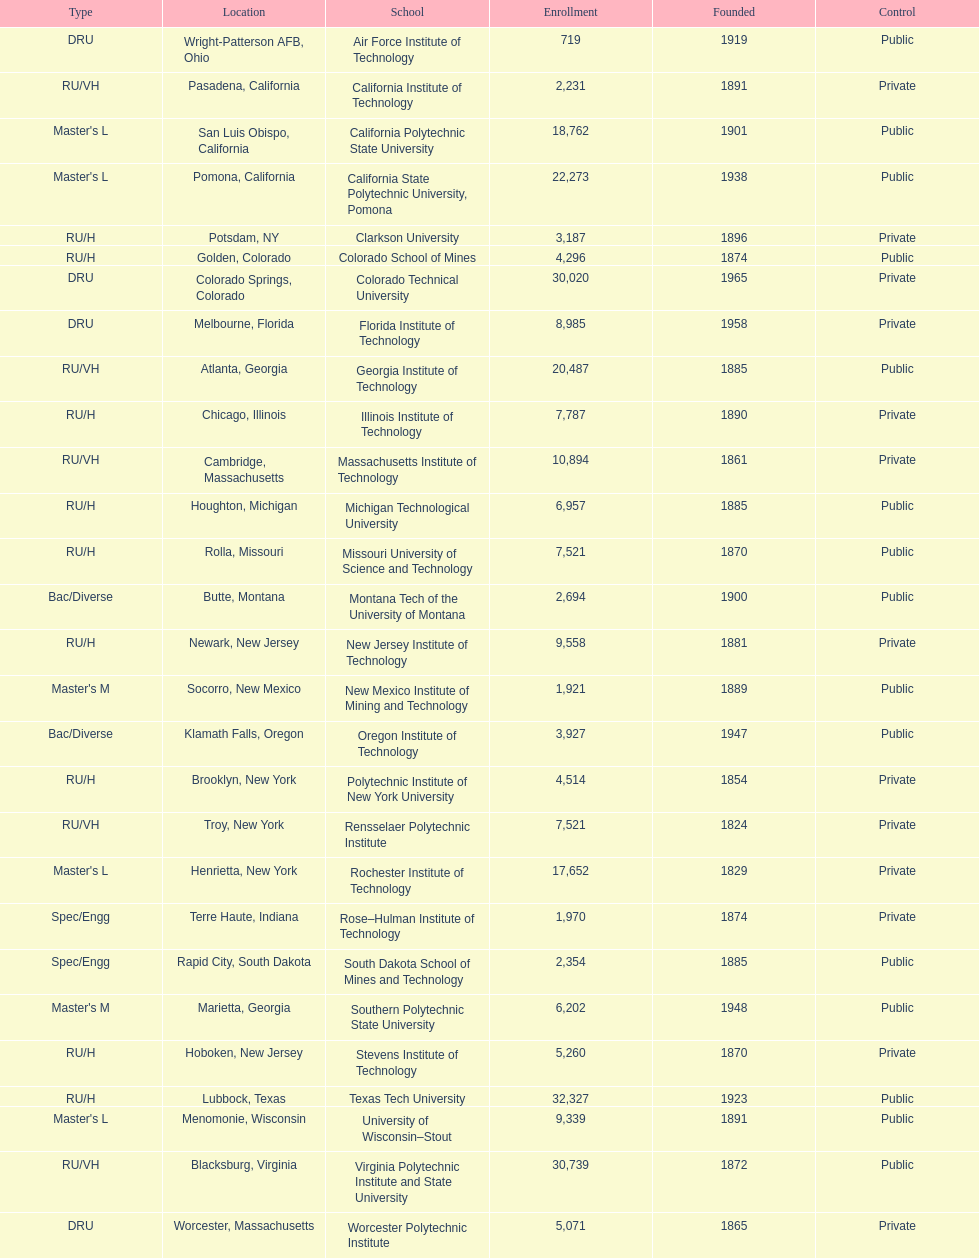What is the difference in enrollment between the top 2 schools listed in the table? 1512. 